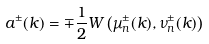Convert formula to latex. <formula><loc_0><loc_0><loc_500><loc_500>a ^ { \pm } ( k ) = \mp \frac { 1 } { 2 } W \left ( \mu _ { n } ^ { \pm } ( k ) , \nu _ { n } ^ { \pm } ( k ) \right )</formula> 